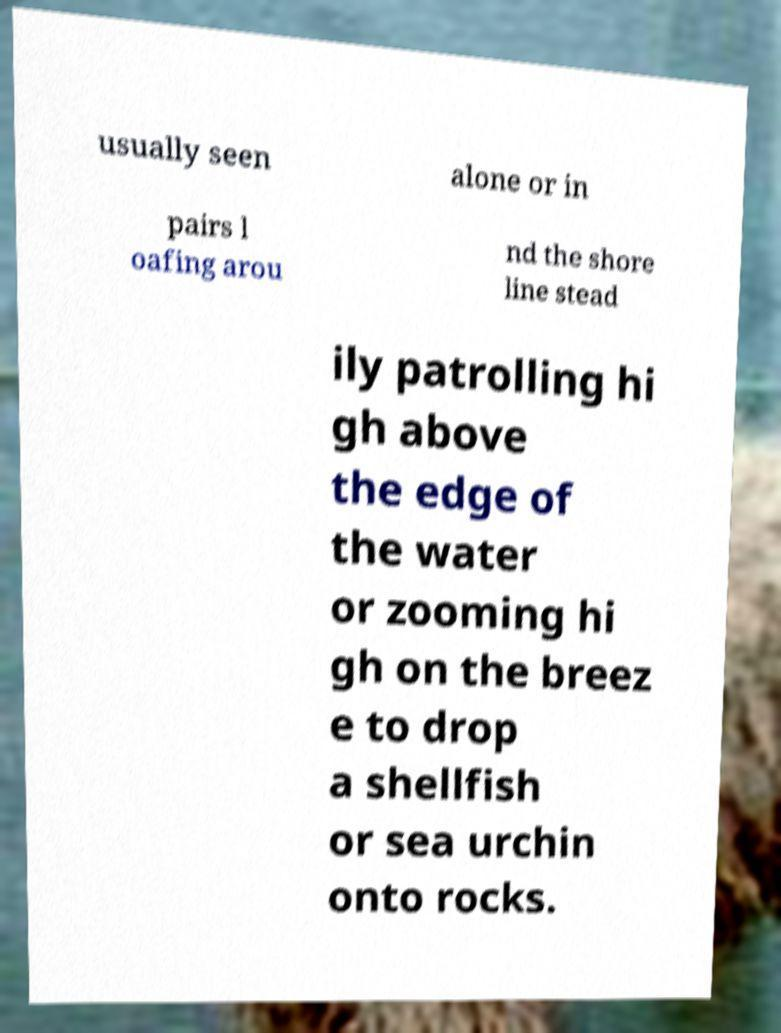There's text embedded in this image that I need extracted. Can you transcribe it verbatim? usually seen alone or in pairs l oafing arou nd the shore line stead ily patrolling hi gh above the edge of the water or zooming hi gh on the breez e to drop a shellfish or sea urchin onto rocks. 